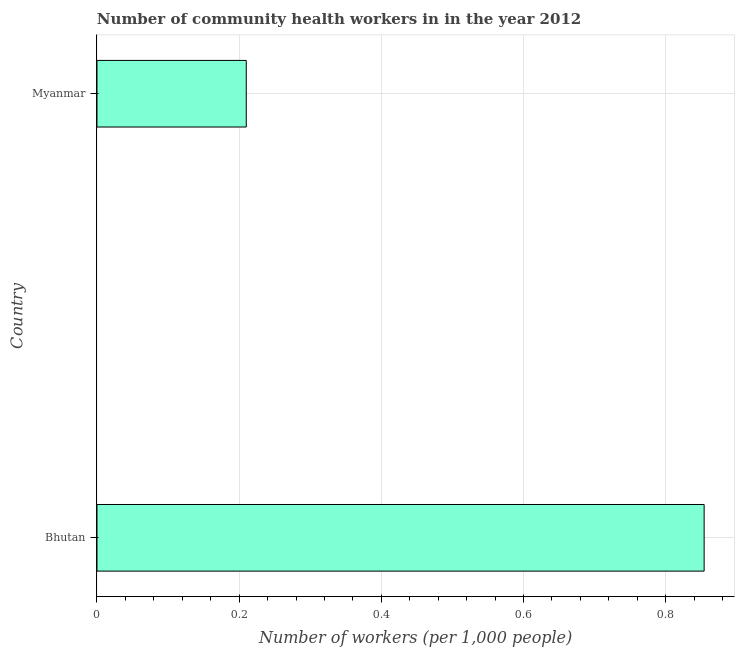Does the graph contain grids?
Offer a terse response. Yes. What is the title of the graph?
Your answer should be very brief. Number of community health workers in in the year 2012. What is the label or title of the X-axis?
Make the answer very short. Number of workers (per 1,0 people). What is the number of community health workers in Myanmar?
Your answer should be very brief. 0.21. Across all countries, what is the maximum number of community health workers?
Your answer should be very brief. 0.85. Across all countries, what is the minimum number of community health workers?
Give a very brief answer. 0.21. In which country was the number of community health workers maximum?
Offer a terse response. Bhutan. In which country was the number of community health workers minimum?
Keep it short and to the point. Myanmar. What is the sum of the number of community health workers?
Provide a short and direct response. 1.06. What is the difference between the number of community health workers in Bhutan and Myanmar?
Your answer should be compact. 0.64. What is the average number of community health workers per country?
Your answer should be compact. 0.53. What is the median number of community health workers?
Offer a terse response. 0.53. In how many countries, is the number of community health workers greater than 0.48 ?
Provide a succinct answer. 1. What is the ratio of the number of community health workers in Bhutan to that in Myanmar?
Keep it short and to the point. 4.07. In how many countries, is the number of community health workers greater than the average number of community health workers taken over all countries?
Keep it short and to the point. 1. How many bars are there?
Ensure brevity in your answer.  2. Are the values on the major ticks of X-axis written in scientific E-notation?
Provide a succinct answer. No. What is the Number of workers (per 1,000 people) of Bhutan?
Give a very brief answer. 0.85. What is the Number of workers (per 1,000 people) of Myanmar?
Your answer should be compact. 0.21. What is the difference between the Number of workers (per 1,000 people) in Bhutan and Myanmar?
Provide a succinct answer. 0.64. What is the ratio of the Number of workers (per 1,000 people) in Bhutan to that in Myanmar?
Keep it short and to the point. 4.07. 